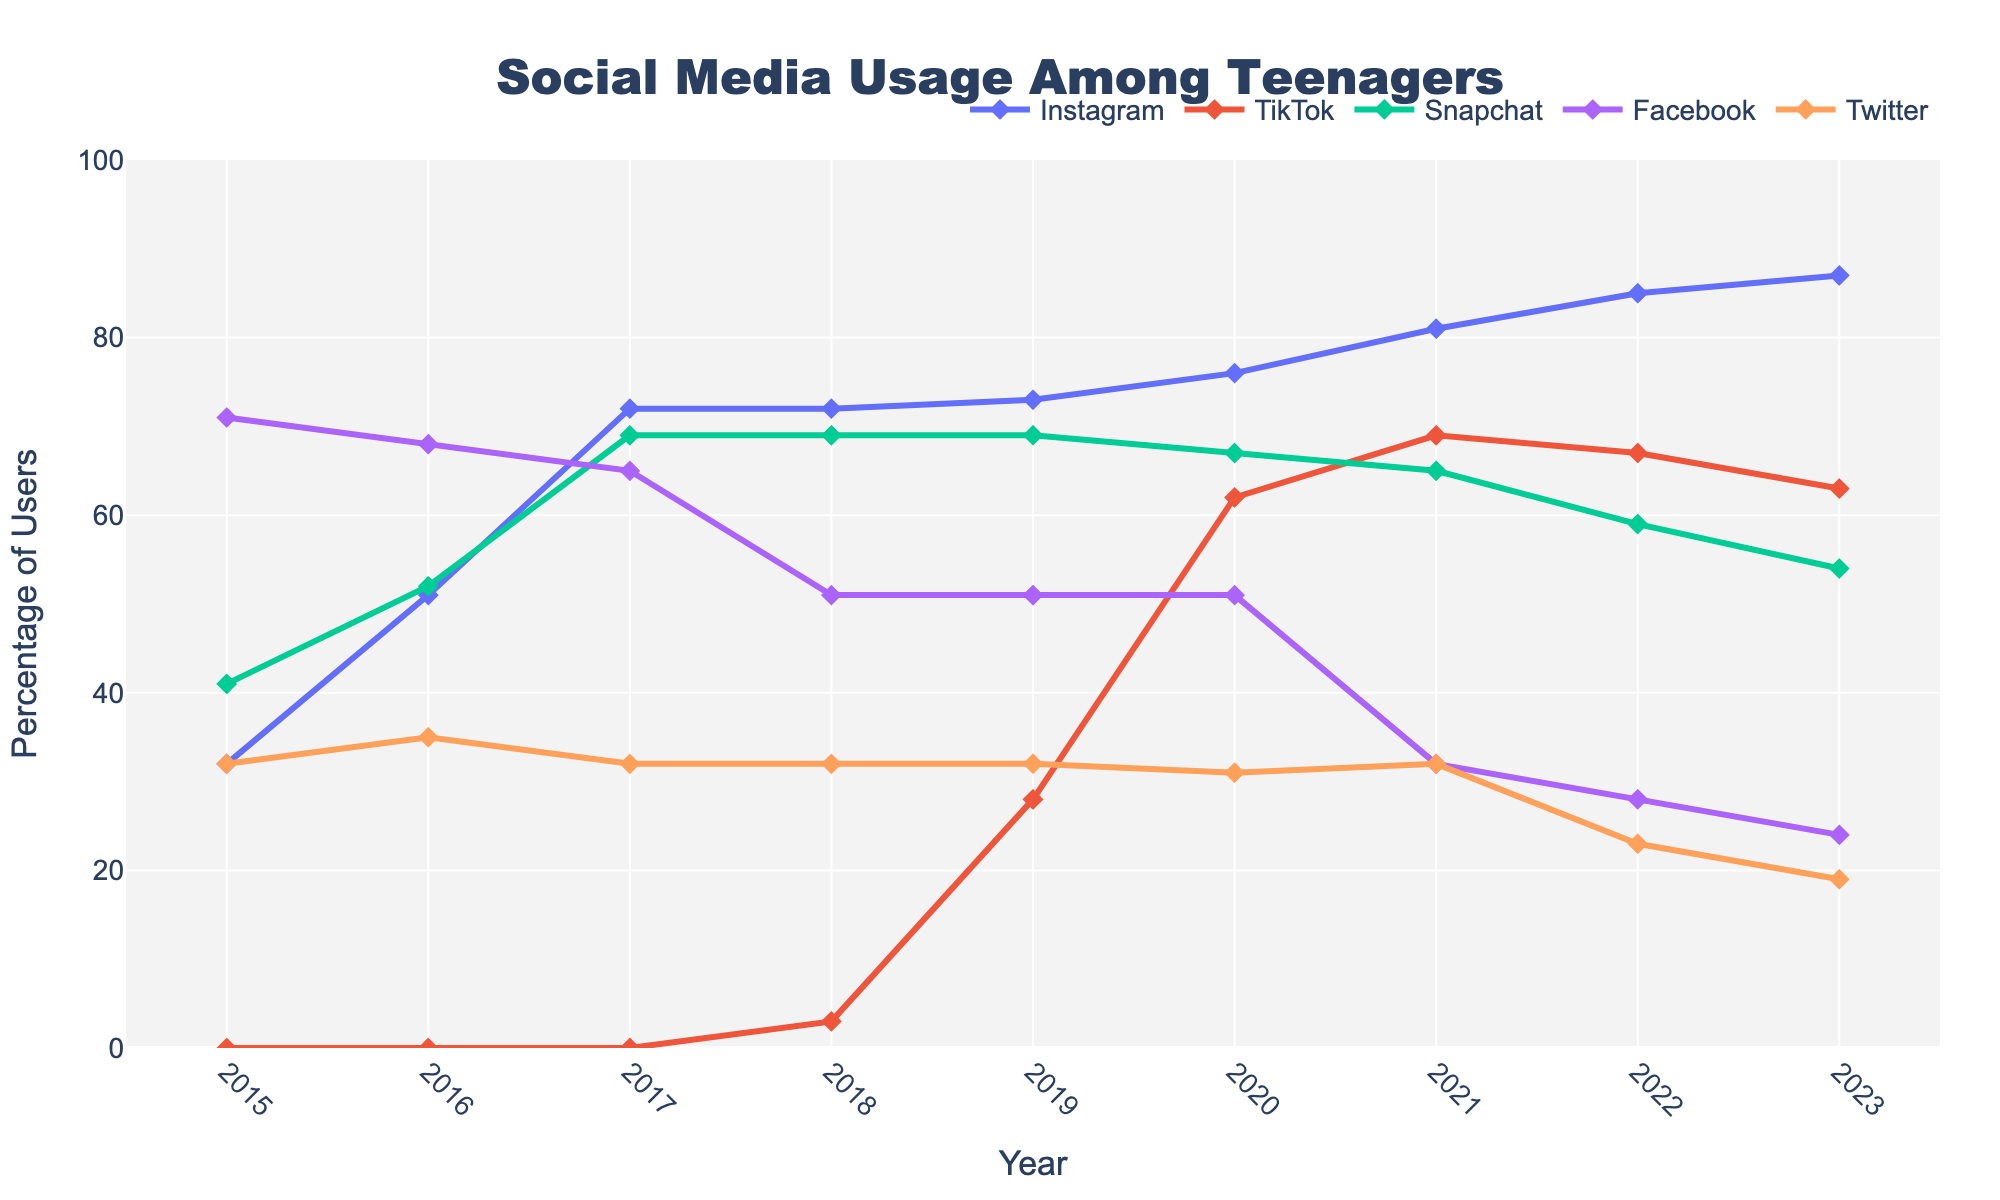What was the change in Instagram usage from 2016 to 2021? To determine the change, we subtract the percentage in 2016 from the percentage in 2021. In 2016, Instagram usage was 51%, and in 2021, it was 81%. So, the change is 81% - 51%.
Answer: 30% Compare the popularity of Snapchat and TikTok in 2018. Which was more popular and by how much? In 2018, Snapchat had a usage of 69%, while TikTok had a usage of 3%. To find the difference, subtract TikTok's usage from Snapchat's usage: 69% - 3%. Snapchat was more popular by this amount.
Answer: 66% Which social media platform showed the most significant rise in usage from 2017 to 2018? By inspecting the line chart for each platform between 2017 and 2018, TikTok usage increased from 0% to 3%, Instagram remained the same at 72%, Snapchat remained constant at 69%, Facebook decreased from 65% to 51%, and Twitter remained constant at 32%. The most significant increase was for TikTok (0% to 3%).
Answer: TikTok What were the years when Facebook was the most and least popular according to the chart? By visual inspection, the highest percentage for Facebook was in 2015 with 71%, and the lowest percentage was in 2023 with 24%.
Answer: Most: 2015, Least: 2023 What is the combined usage percentage of Instagram and Snapchat in 2020? To find the combined usage, we add the percentages for Instagram and Snapchat in 2020. Instagram is at 76%, and Snapchat is at 67%. So, the combined usage is 76% + 67%.
Answer: 143% How did Twitter's popularity change over the span of the years presented? Examining the data points for Twitter across the years: 2015: 32%, 2016: 35%, 2017: 32%, 2018: 32%, 2019: 32%, 2020: 31%, 2021: 32%, 2022: 23%, 2023: 19%. Assessing the trend, it initially fluctuates slightly but then shows a steady decline from 2020 to 2023.
Answer: Declined Compare the trends of TikTok and Instagram from 2019 to 2022. From 2019 to 2022, TikTok usage increased from 28% to 67%, while Instagram usage rose from 73% to 85%. By observing the slopes, both platforms are trending upward, but TikTok shows a sharper increase compared to Instagram.
Answer: Both increased, but TikTok increased more sharply What was the total percentage of users on all platforms in 2019? To find the total percentage, sum the percentages of all platforms in 2019: Instagram (73%) + TikTok (28%) + Snapchat (69%) + Facebook (51%) + Twitter (32%).
Answer: 253% Which platform had the smallest change in usage over the years, and what was that change? To identify the platform with the smallest change, calculate the change for each platform from 2015 to 2023. Instagram changed from 32% to 87% (55% increase), TikTok from 0% to 63% (63% increase), Snapchat from 41% to 54% (13% increase), Facebook from 71% to 24% (47% decrease), Twitter from 32% to 19% (13% decrease). Snapchat and Twitter both had the smallest absolute change of 13%.
Answer: Snapchat and Twitter, 13% 